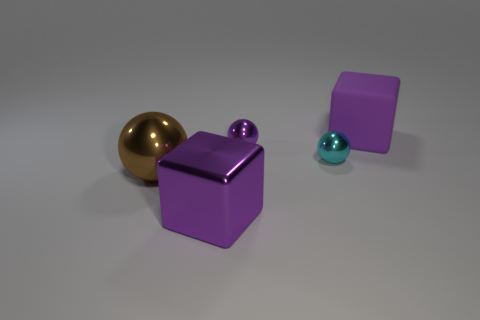Add 3 balls. How many objects exist? 8 Subtract all balls. How many objects are left? 2 Subtract 1 brown balls. How many objects are left? 4 Subtract all yellow metallic blocks. Subtract all large metal blocks. How many objects are left? 4 Add 1 purple matte objects. How many purple matte objects are left? 2 Add 2 big brown balls. How many big brown balls exist? 3 